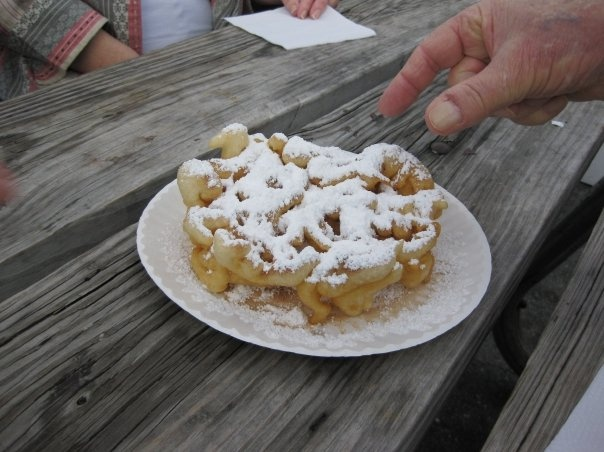Describe the objects in this image and their specific colors. I can see dining table in gray, darkgray, black, and lightgray tones, people in gray, brown, and maroon tones, and people in gray and black tones in this image. 